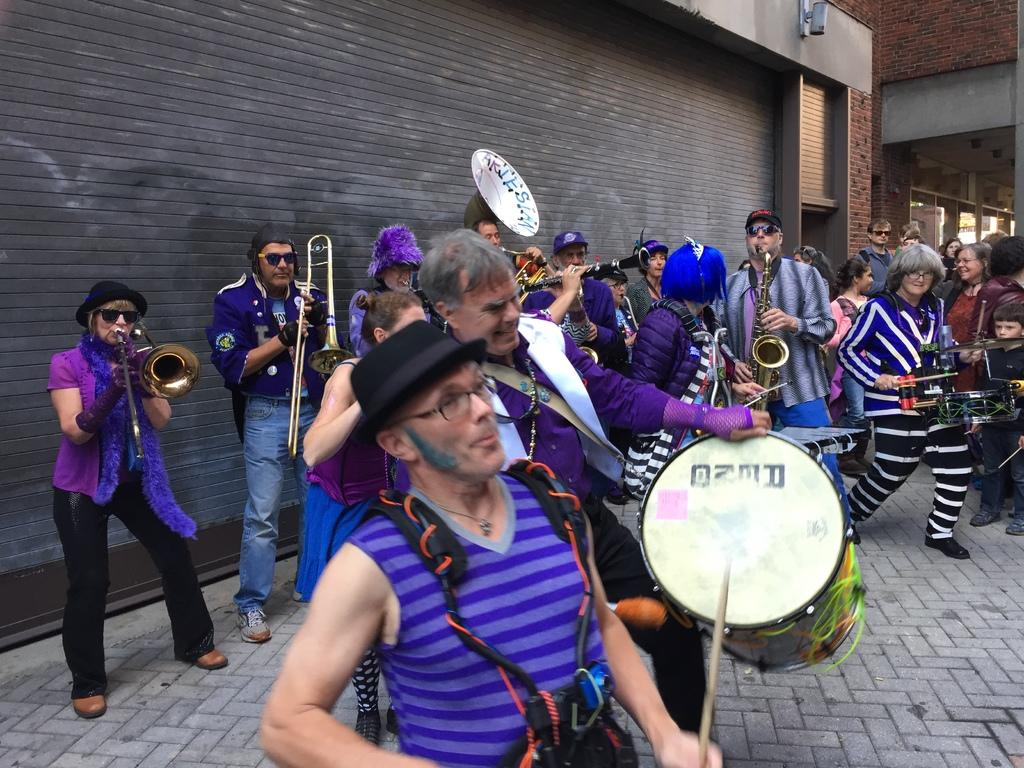What are the people in the image doing? The people in the image are dancing and playing musical instruments. Can you describe the composition of the group? There are both men and women in the group. What can be seen in the background of the image? There is a wall in the background of the image. What type of jam is being spread on the cow in the image? There is no cow or jam present in the image; the people are dancing and playing musical instruments. How does the rhythm of the music affect the cow in the image? There is no cow present in the image, so it cannot be affected by the rhythm of the music. 